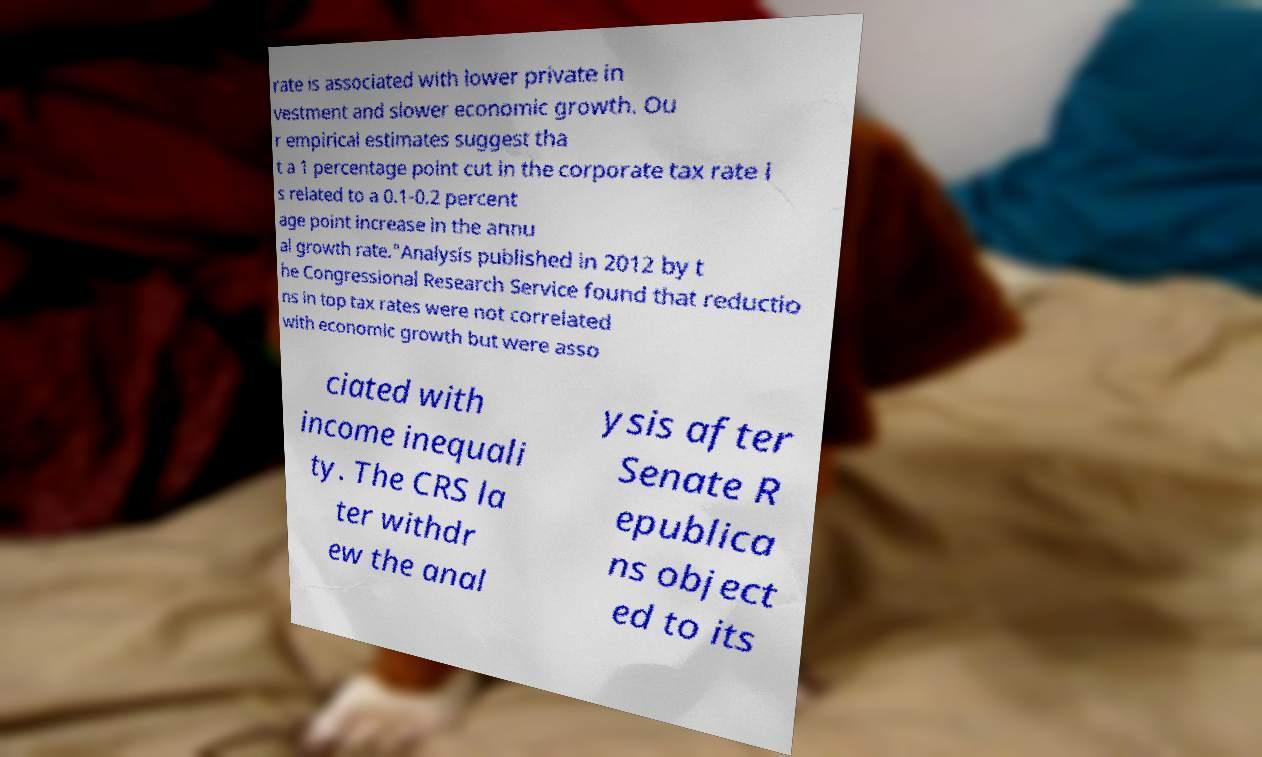Please read and relay the text visible in this image. What does it say? rate is associated with lower private in vestment and slower economic growth. Ou r empirical estimates suggest tha t a 1 percentage point cut in the corporate tax rate i s related to a 0.1-0.2 percent age point increase in the annu al growth rate."Analysis published in 2012 by t he Congressional Research Service found that reductio ns in top tax rates were not correlated with economic growth but were asso ciated with income inequali ty. The CRS la ter withdr ew the anal ysis after Senate R epublica ns object ed to its 